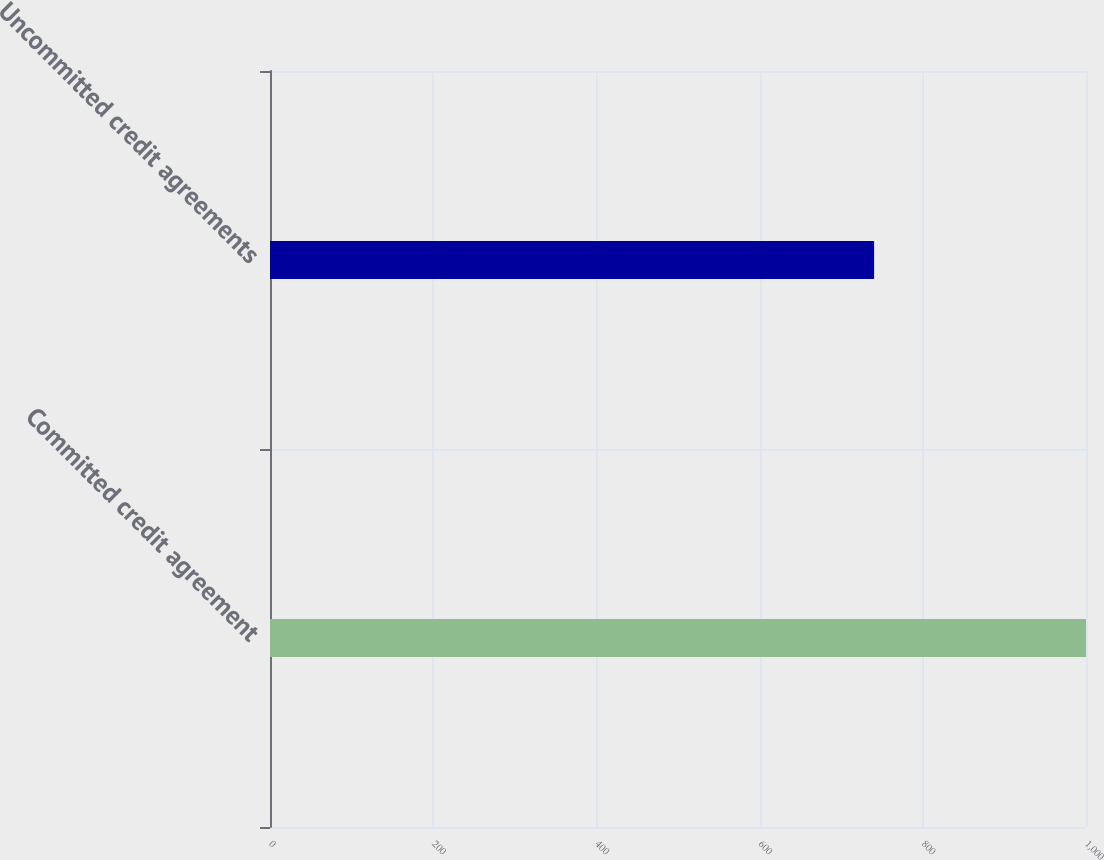<chart> <loc_0><loc_0><loc_500><loc_500><bar_chart><fcel>Committed credit agreement<fcel>Uncommitted credit agreements<nl><fcel>1000<fcel>740.3<nl></chart> 